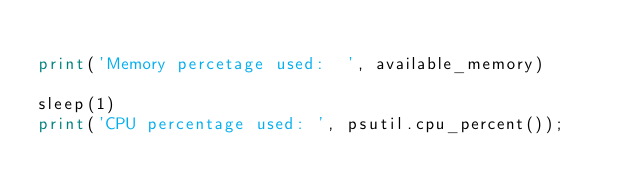Convert code to text. <code><loc_0><loc_0><loc_500><loc_500><_Python_>
print('Memory percetage used:  ', available_memory)

sleep(1)
print('CPU percentage used: ', psutil.cpu_percent());

</code> 